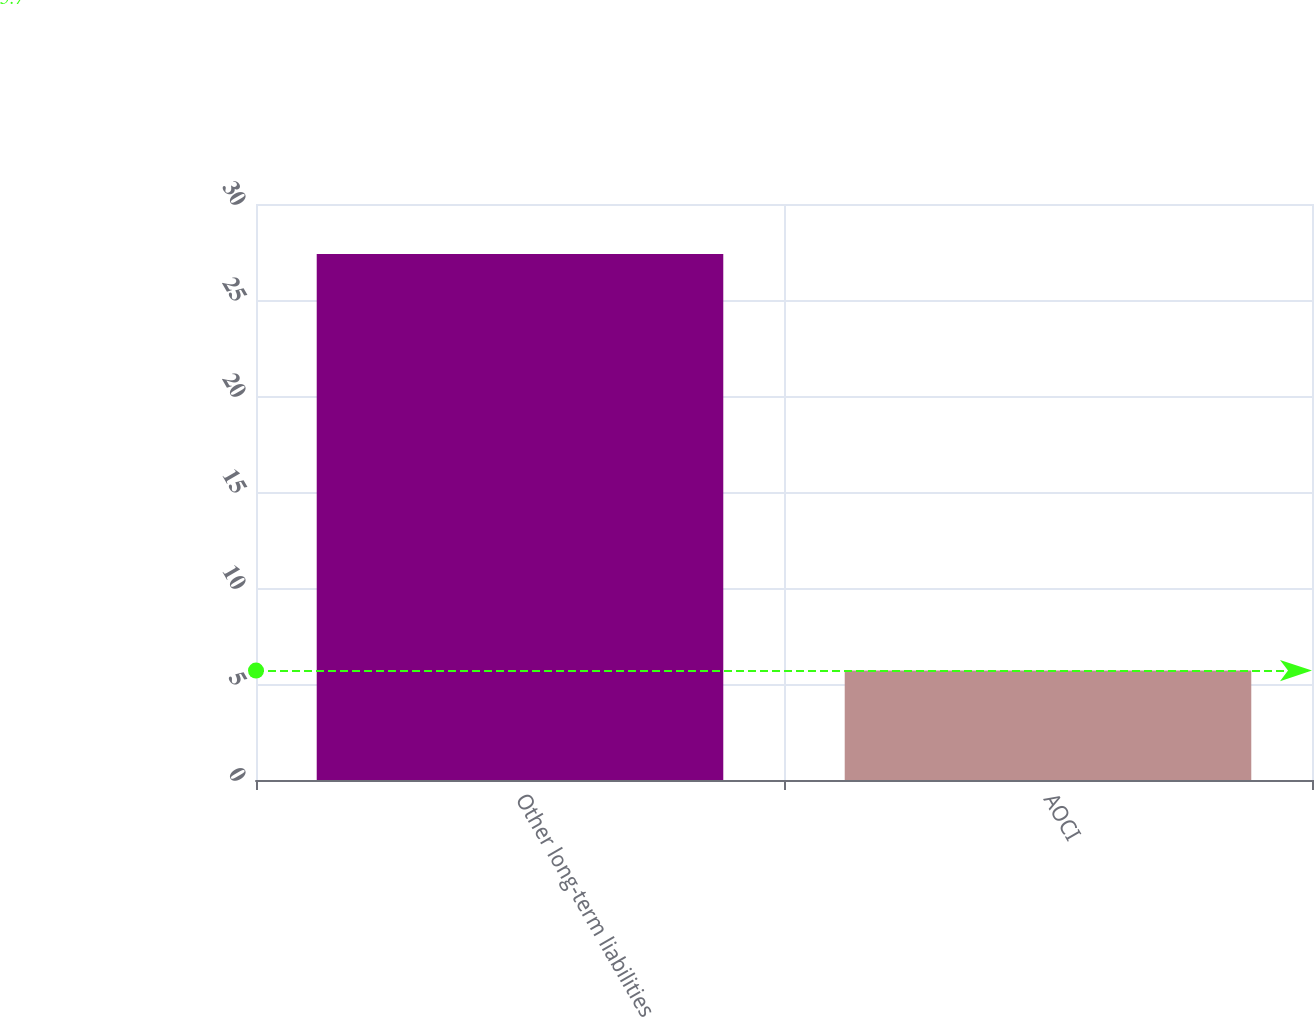Convert chart to OTSL. <chart><loc_0><loc_0><loc_500><loc_500><bar_chart><fcel>Other long-term liabilities<fcel>AOCI<nl><fcel>27.4<fcel>5.7<nl></chart> 